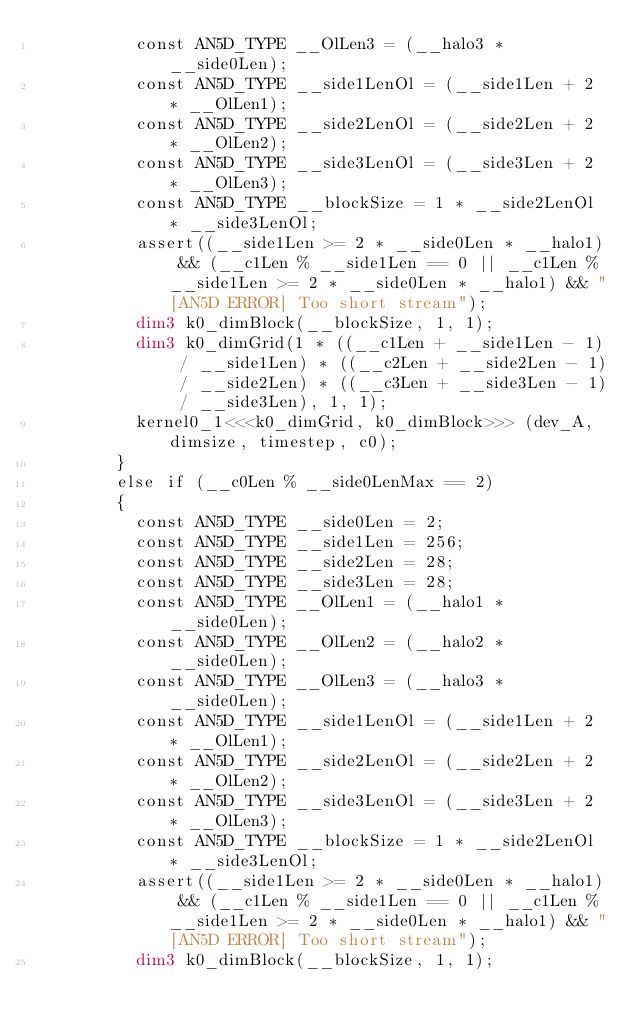<code> <loc_0><loc_0><loc_500><loc_500><_Cuda_>          const AN5D_TYPE __OlLen3 = (__halo3 * __side0Len);
          const AN5D_TYPE __side1LenOl = (__side1Len + 2 * __OlLen1);
          const AN5D_TYPE __side2LenOl = (__side2Len + 2 * __OlLen2);
          const AN5D_TYPE __side3LenOl = (__side3Len + 2 * __OlLen3);
          const AN5D_TYPE __blockSize = 1 * __side2LenOl * __side3LenOl;
          assert((__side1Len >= 2 * __side0Len * __halo1) && (__c1Len % __side1Len == 0 || __c1Len % __side1Len >= 2 * __side0Len * __halo1) && "[AN5D ERROR] Too short stream");
          dim3 k0_dimBlock(__blockSize, 1, 1);
          dim3 k0_dimGrid(1 * ((__c1Len + __side1Len - 1) / __side1Len) * ((__c2Len + __side2Len - 1) / __side2Len) * ((__c3Len + __side3Len - 1) / __side3Len), 1, 1);
          kernel0_1<<<k0_dimGrid, k0_dimBlock>>> (dev_A, dimsize, timestep, c0);
        }
        else if (__c0Len % __side0LenMax == 2)
        {
          const AN5D_TYPE __side0Len = 2;
          const AN5D_TYPE __side1Len = 256;
          const AN5D_TYPE __side2Len = 28;
          const AN5D_TYPE __side3Len = 28;
          const AN5D_TYPE __OlLen1 = (__halo1 * __side0Len);
          const AN5D_TYPE __OlLen2 = (__halo2 * __side0Len);
          const AN5D_TYPE __OlLen3 = (__halo3 * __side0Len);
          const AN5D_TYPE __side1LenOl = (__side1Len + 2 * __OlLen1);
          const AN5D_TYPE __side2LenOl = (__side2Len + 2 * __OlLen2);
          const AN5D_TYPE __side3LenOl = (__side3Len + 2 * __OlLen3);
          const AN5D_TYPE __blockSize = 1 * __side2LenOl * __side3LenOl;
          assert((__side1Len >= 2 * __side0Len * __halo1) && (__c1Len % __side1Len == 0 || __c1Len % __side1Len >= 2 * __side0Len * __halo1) && "[AN5D ERROR] Too short stream");
          dim3 k0_dimBlock(__blockSize, 1, 1);</code> 